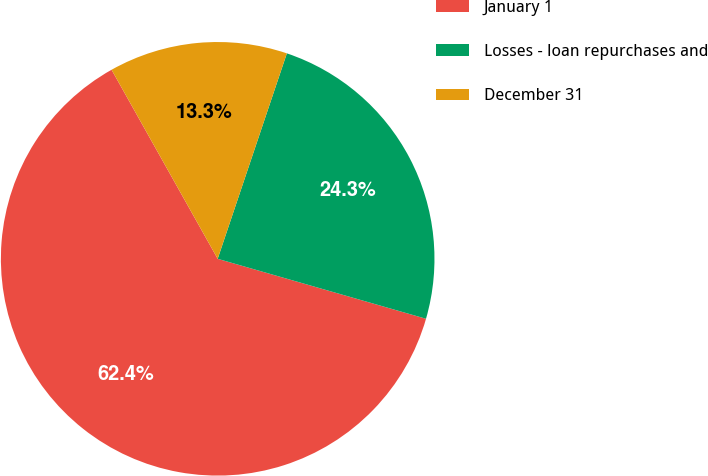Convert chart. <chart><loc_0><loc_0><loc_500><loc_500><pie_chart><fcel>January 1<fcel>Losses - loan repurchases and<fcel>December 31<nl><fcel>62.4%<fcel>24.29%<fcel>13.31%<nl></chart> 